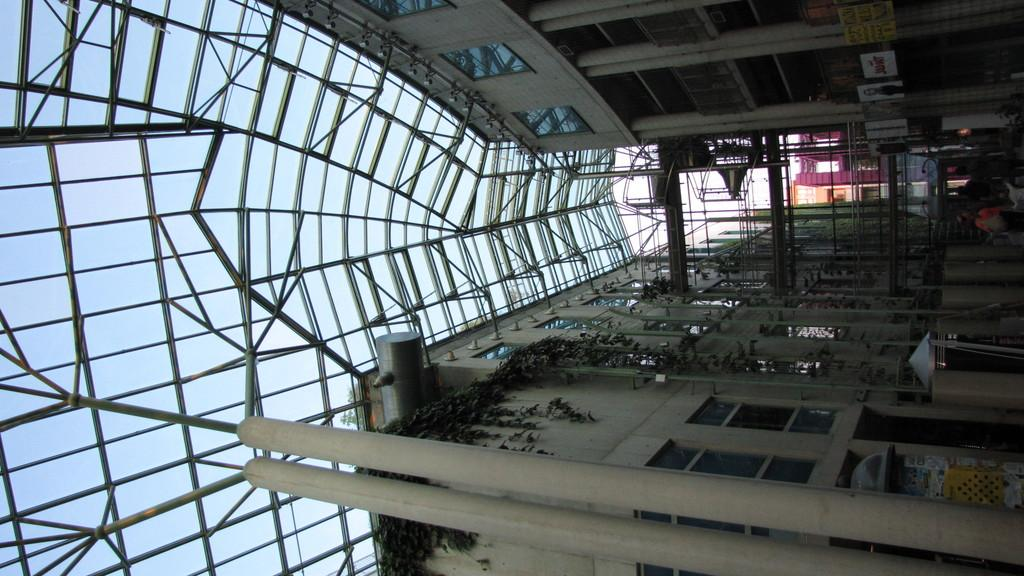What type of structure is present in the image? There is a building in the image. What can be seen on the left side of the image? There are rods on the left side of the image. What part of the building is visible on the right side of the image? The right side of the image shows the terrace of the building. What is visible at the top of the image? There is a roof visible at the top of the image. What type of shock can be seen on the terrace of the building in the image? There is no shock present on the terrace of the building in the image. 